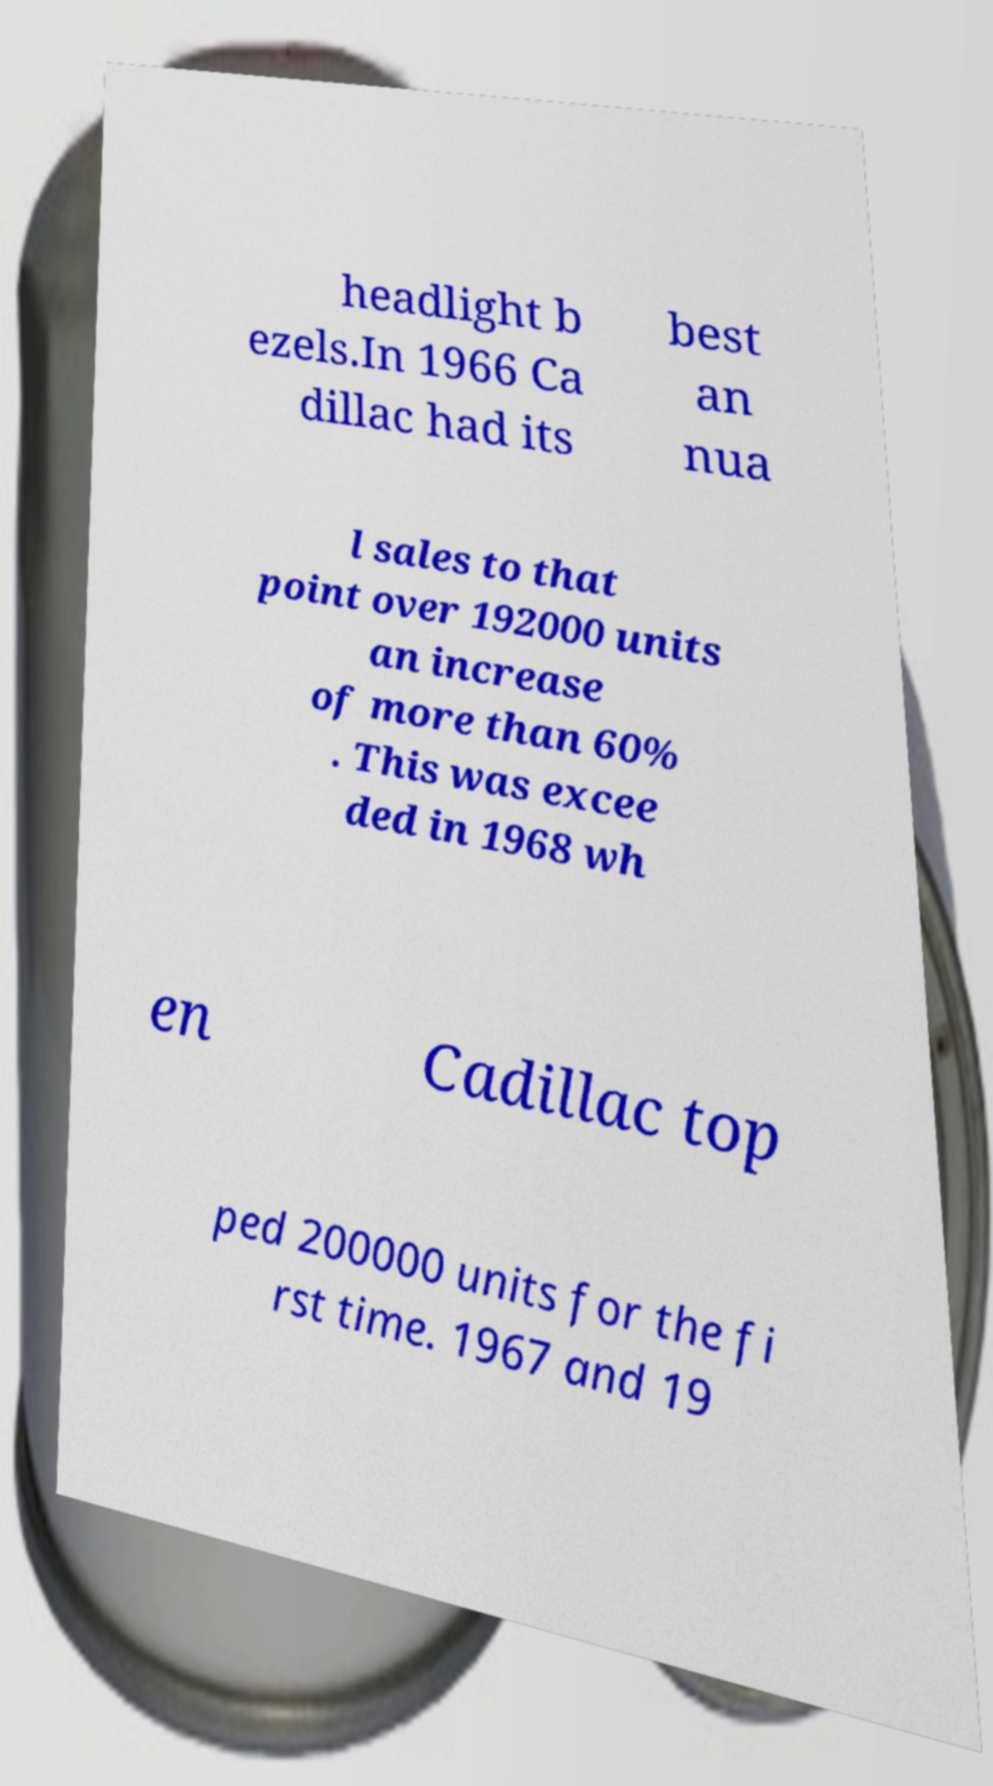Could you extract and type out the text from this image? headlight b ezels.In 1966 Ca dillac had its best an nua l sales to that point over 192000 units an increase of more than 60% . This was excee ded in 1968 wh en Cadillac top ped 200000 units for the fi rst time. 1967 and 19 